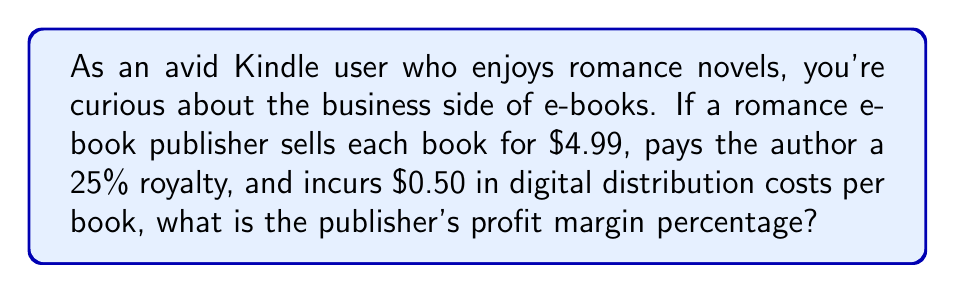Help me with this question. Let's break this down step-by-step:

1. Define the variables:
   $P$ = Price of the e-book = $4.99
   $R$ = Royalty percentage = 25% = 0.25
   $C$ = Distribution costs = $0.50

2. Calculate the royalty amount per book:
   Royalty = $P \times R = 4.99 \times 0.25 = $1.2475

3. Calculate the total cost per book:
   Total cost = Royalty + Distribution costs
   $TC = 1.2475 + 0.50 = $1.7475

4. Calculate the profit per book:
   Profit = Price - Total cost
   $Profit = P - TC = 4.99 - 1.7475 = $3.2425

5. Calculate the profit margin percentage:
   Profit Margin % = $\frac{\text{Profit}}{\text{Price}} \times 100\%$
   
   $$\text{Profit Margin} \% = \frac{3.2425}{4.99} \times 100\% = 64.98\%$$
Answer: 64.98% 